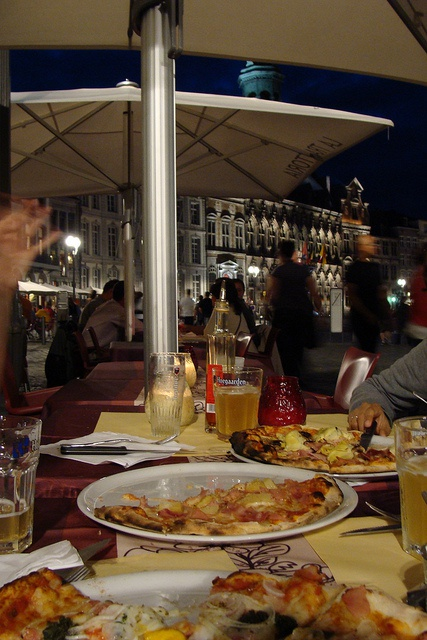Describe the objects in this image and their specific colors. I can see dining table in maroon, tan, black, and olive tones, umbrella in maroon, black, and darkgray tones, pizza in maroon, olive, and tan tones, people in maroon, black, and gray tones, and pizza in maroon, olive, and tan tones in this image. 